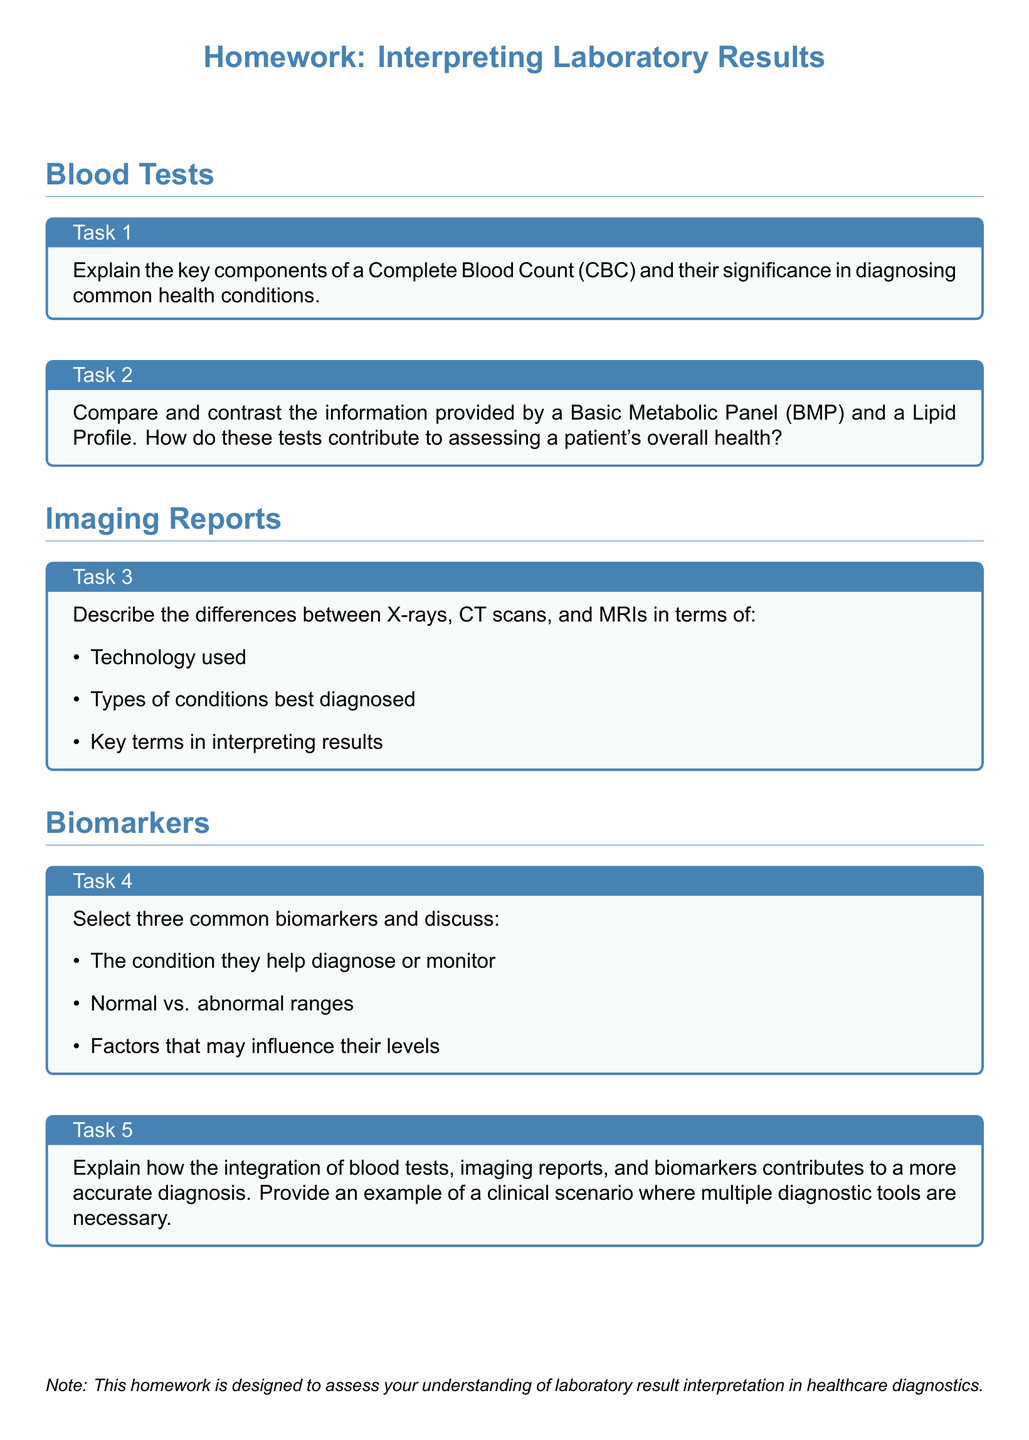What is the title of the homework? The title of the homework is presented in a bold format at the top of the document.
Answer: Homework: Interpreting Laboratory Results How many tasks are there in total? The document lists a total of five tasks under different sections.
Answer: 5 What specific component is discussed in Task 1? Task 1 focuses on the Complete Blood Count (CBC) and its significance in diagnosing health conditions.
Answer: Complete Blood Count (CBC) Which imaging technique is mentioned as being able to diagnose conditions effectively? The document highlights three imaging techniques, including X-rays, CT scans, and MRIs without favoring one over the others.
Answer: X-rays, CT scans, and MRIs What is one common biomarker that could be selected in Task 4? Task 4 requires discussing three common biomarkers, any of which can be selected; for example, cholesterol is a well-known biomarker.
Answer: Cholesterol What is the color of the box for each task? Each task is placed in a box with a light blue background color as indicated in the document.
Answer: Light blue What is the main focus of Task 5? Task 5 emphasizes the integration of different diagnostic methods for accurate diagnosis with examples.
Answer: Integration of diagnostic methods What type of report is being compared in Task 3? Task 3 compares various imaging reports including X-rays, CT scans, and MRIs.
Answer: Imaging reports 